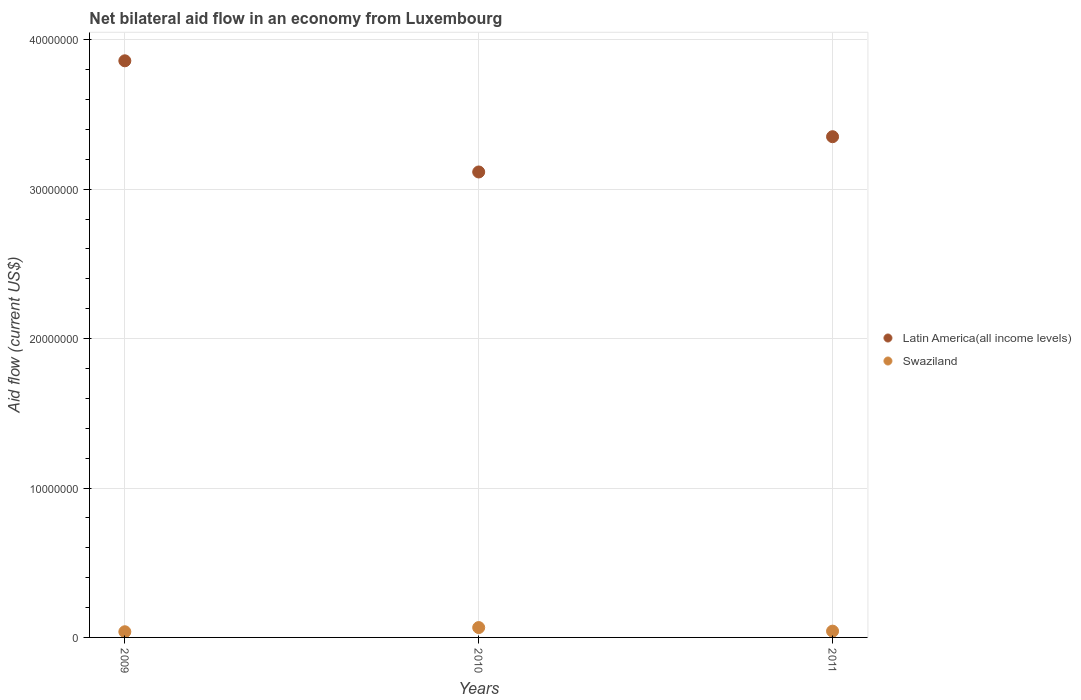How many different coloured dotlines are there?
Provide a short and direct response. 2. Is the number of dotlines equal to the number of legend labels?
Your answer should be very brief. Yes. Across all years, what is the maximum net bilateral aid flow in Latin America(all income levels)?
Your response must be concise. 3.86e+07. Across all years, what is the minimum net bilateral aid flow in Swaziland?
Make the answer very short. 3.80e+05. In which year was the net bilateral aid flow in Swaziland maximum?
Your answer should be compact. 2010. In which year was the net bilateral aid flow in Swaziland minimum?
Ensure brevity in your answer.  2009. What is the total net bilateral aid flow in Latin America(all income levels) in the graph?
Offer a very short reply. 1.03e+08. What is the difference between the net bilateral aid flow in Latin America(all income levels) in 2010 and that in 2011?
Give a very brief answer. -2.36e+06. What is the difference between the net bilateral aid flow in Swaziland in 2009 and the net bilateral aid flow in Latin America(all income levels) in 2010?
Offer a terse response. -3.08e+07. What is the average net bilateral aid flow in Swaziland per year?
Offer a terse response. 4.87e+05. In the year 2010, what is the difference between the net bilateral aid flow in Latin America(all income levels) and net bilateral aid flow in Swaziland?
Offer a very short reply. 3.05e+07. In how many years, is the net bilateral aid flow in Swaziland greater than 36000000 US$?
Give a very brief answer. 0. What is the ratio of the net bilateral aid flow in Latin America(all income levels) in 2009 to that in 2010?
Your answer should be very brief. 1.24. Is the net bilateral aid flow in Swaziland in 2009 less than that in 2011?
Offer a terse response. Yes. What is the difference between the highest and the second highest net bilateral aid flow in Swaziland?
Your response must be concise. 2.40e+05. What is the difference between the highest and the lowest net bilateral aid flow in Latin America(all income levels)?
Make the answer very short. 7.44e+06. Is the sum of the net bilateral aid flow in Swaziland in 2009 and 2010 greater than the maximum net bilateral aid flow in Latin America(all income levels) across all years?
Ensure brevity in your answer.  No. Is the net bilateral aid flow in Latin America(all income levels) strictly less than the net bilateral aid flow in Swaziland over the years?
Provide a short and direct response. No. How many dotlines are there?
Make the answer very short. 2. How many years are there in the graph?
Offer a very short reply. 3. What is the difference between two consecutive major ticks on the Y-axis?
Offer a very short reply. 1.00e+07. Where does the legend appear in the graph?
Your response must be concise. Center right. How are the legend labels stacked?
Your response must be concise. Vertical. What is the title of the graph?
Your answer should be very brief. Net bilateral aid flow in an economy from Luxembourg. Does "Colombia" appear as one of the legend labels in the graph?
Keep it short and to the point. No. What is the Aid flow (current US$) of Latin America(all income levels) in 2009?
Your response must be concise. 3.86e+07. What is the Aid flow (current US$) in Latin America(all income levels) in 2010?
Keep it short and to the point. 3.12e+07. What is the Aid flow (current US$) in Swaziland in 2010?
Ensure brevity in your answer.  6.60e+05. What is the Aid flow (current US$) of Latin America(all income levels) in 2011?
Your response must be concise. 3.35e+07. Across all years, what is the maximum Aid flow (current US$) of Latin America(all income levels)?
Your answer should be compact. 3.86e+07. Across all years, what is the maximum Aid flow (current US$) in Swaziland?
Make the answer very short. 6.60e+05. Across all years, what is the minimum Aid flow (current US$) in Latin America(all income levels)?
Ensure brevity in your answer.  3.12e+07. Across all years, what is the minimum Aid flow (current US$) in Swaziland?
Offer a very short reply. 3.80e+05. What is the total Aid flow (current US$) in Latin America(all income levels) in the graph?
Ensure brevity in your answer.  1.03e+08. What is the total Aid flow (current US$) of Swaziland in the graph?
Keep it short and to the point. 1.46e+06. What is the difference between the Aid flow (current US$) in Latin America(all income levels) in 2009 and that in 2010?
Provide a succinct answer. 7.44e+06. What is the difference between the Aid flow (current US$) of Swaziland in 2009 and that in 2010?
Provide a short and direct response. -2.80e+05. What is the difference between the Aid flow (current US$) in Latin America(all income levels) in 2009 and that in 2011?
Your response must be concise. 5.08e+06. What is the difference between the Aid flow (current US$) in Swaziland in 2009 and that in 2011?
Give a very brief answer. -4.00e+04. What is the difference between the Aid flow (current US$) of Latin America(all income levels) in 2010 and that in 2011?
Offer a terse response. -2.36e+06. What is the difference between the Aid flow (current US$) of Swaziland in 2010 and that in 2011?
Offer a terse response. 2.40e+05. What is the difference between the Aid flow (current US$) in Latin America(all income levels) in 2009 and the Aid flow (current US$) in Swaziland in 2010?
Your answer should be compact. 3.79e+07. What is the difference between the Aid flow (current US$) of Latin America(all income levels) in 2009 and the Aid flow (current US$) of Swaziland in 2011?
Provide a succinct answer. 3.82e+07. What is the difference between the Aid flow (current US$) in Latin America(all income levels) in 2010 and the Aid flow (current US$) in Swaziland in 2011?
Your answer should be compact. 3.07e+07. What is the average Aid flow (current US$) in Latin America(all income levels) per year?
Offer a very short reply. 3.44e+07. What is the average Aid flow (current US$) of Swaziland per year?
Your response must be concise. 4.87e+05. In the year 2009, what is the difference between the Aid flow (current US$) in Latin America(all income levels) and Aid flow (current US$) in Swaziland?
Make the answer very short. 3.82e+07. In the year 2010, what is the difference between the Aid flow (current US$) in Latin America(all income levels) and Aid flow (current US$) in Swaziland?
Offer a terse response. 3.05e+07. In the year 2011, what is the difference between the Aid flow (current US$) of Latin America(all income levels) and Aid flow (current US$) of Swaziland?
Offer a very short reply. 3.31e+07. What is the ratio of the Aid flow (current US$) in Latin America(all income levels) in 2009 to that in 2010?
Ensure brevity in your answer.  1.24. What is the ratio of the Aid flow (current US$) of Swaziland in 2009 to that in 2010?
Offer a very short reply. 0.58. What is the ratio of the Aid flow (current US$) in Latin America(all income levels) in 2009 to that in 2011?
Make the answer very short. 1.15. What is the ratio of the Aid flow (current US$) in Swaziland in 2009 to that in 2011?
Offer a very short reply. 0.9. What is the ratio of the Aid flow (current US$) of Latin America(all income levels) in 2010 to that in 2011?
Provide a succinct answer. 0.93. What is the ratio of the Aid flow (current US$) of Swaziland in 2010 to that in 2011?
Provide a short and direct response. 1.57. What is the difference between the highest and the second highest Aid flow (current US$) of Latin America(all income levels)?
Offer a very short reply. 5.08e+06. What is the difference between the highest and the lowest Aid flow (current US$) of Latin America(all income levels)?
Make the answer very short. 7.44e+06. 